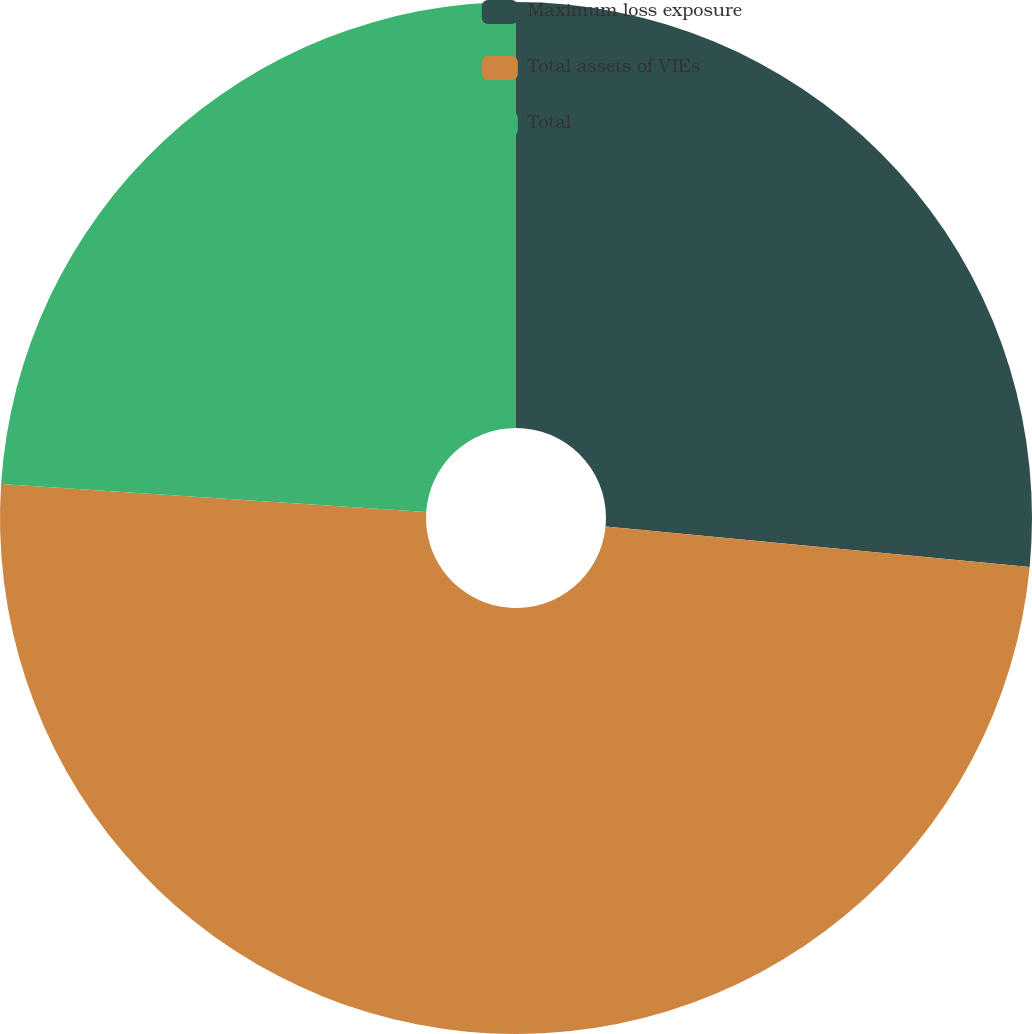Convert chart to OTSL. <chart><loc_0><loc_0><loc_500><loc_500><pie_chart><fcel>Maximum loss exposure<fcel>Total assets of VIEs<fcel>Total<nl><fcel>26.51%<fcel>49.54%<fcel>23.95%<nl></chart> 